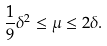<formula> <loc_0><loc_0><loc_500><loc_500>\frac { 1 } { 9 } \delta ^ { 2 } \leq \mu \leq 2 \delta .</formula> 